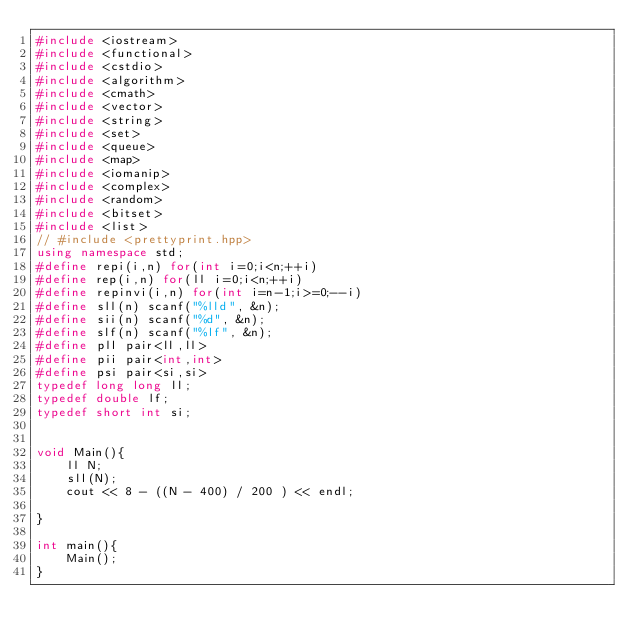<code> <loc_0><loc_0><loc_500><loc_500><_C++_>#include <iostream>
#include <functional>
#include <cstdio>
#include <algorithm>
#include <cmath>
#include <vector>
#include <string>
#include <set>
#include <queue>
#include <map>
#include <iomanip>
#include <complex>
#include <random>
#include <bitset>
#include <list>
// #include <prettyprint.hpp>
using namespace std;
#define repi(i,n) for(int i=0;i<n;++i)
#define rep(i,n) for(ll i=0;i<n;++i)
#define repinvi(i,n) for(int i=n-1;i>=0;--i)
#define sll(n) scanf("%lld", &n);
#define sii(n) scanf("%d", &n);
#define slf(n) scanf("%lf", &n);
#define pll pair<ll,ll>
#define pii pair<int,int>
#define psi pair<si,si>
typedef long long ll;
typedef double lf;
typedef short int si;


void Main(){
    ll N;
    sll(N);
    cout << 8 - ((N - 400) / 200 ) << endl;

}

int main(){
    Main();
}</code> 